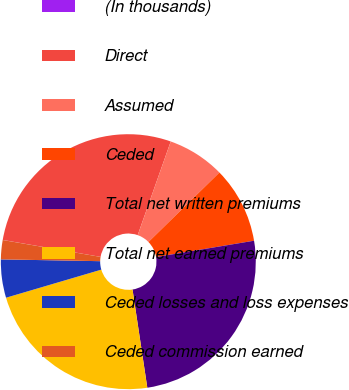<chart> <loc_0><loc_0><loc_500><loc_500><pie_chart><fcel>(In thousands)<fcel>Direct<fcel>Assumed<fcel>Ceded<fcel>Total net written premiums<fcel>Total net earned premiums<fcel>Ceded losses and loss expenses<fcel>Ceded commission earned<nl><fcel>0.01%<fcel>27.67%<fcel>7.27%<fcel>9.7%<fcel>25.25%<fcel>22.82%<fcel>4.85%<fcel>2.43%<nl></chart> 